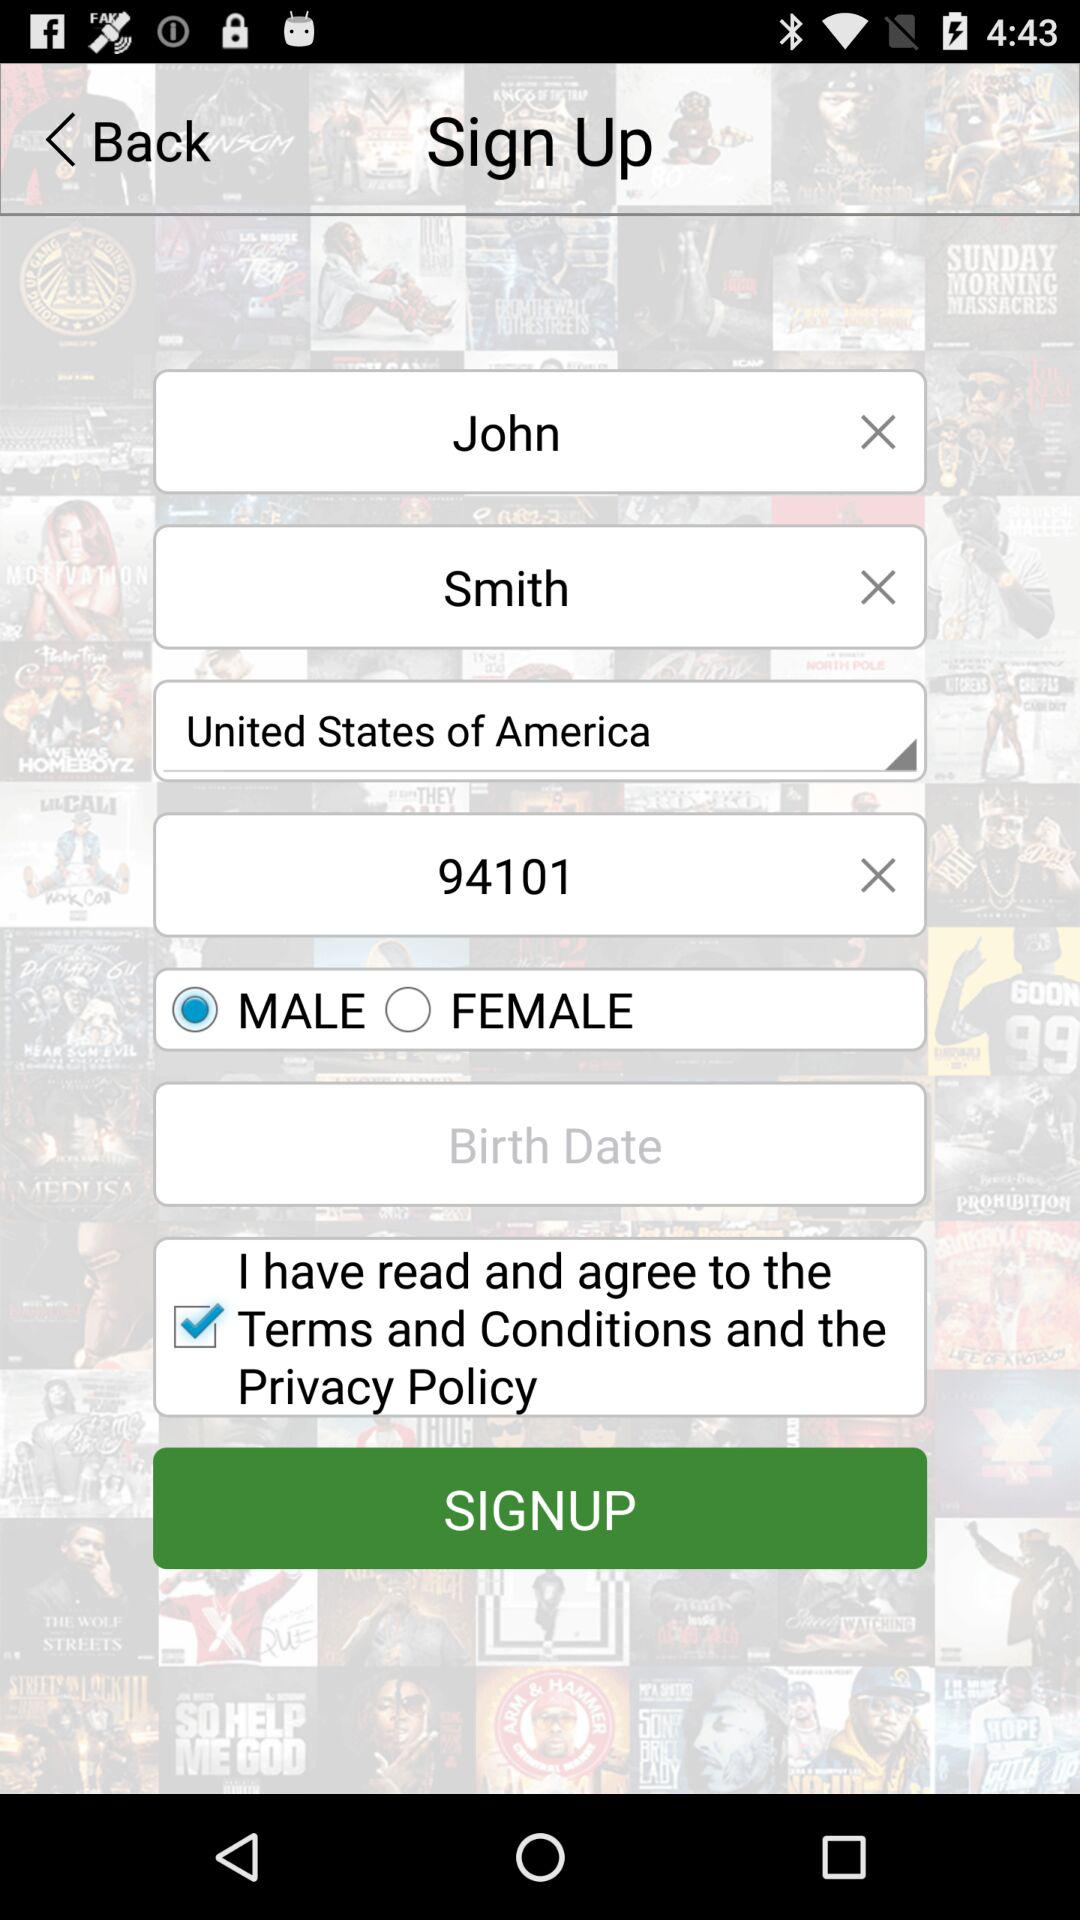Which country is selected? The selected country is the United States of America. 